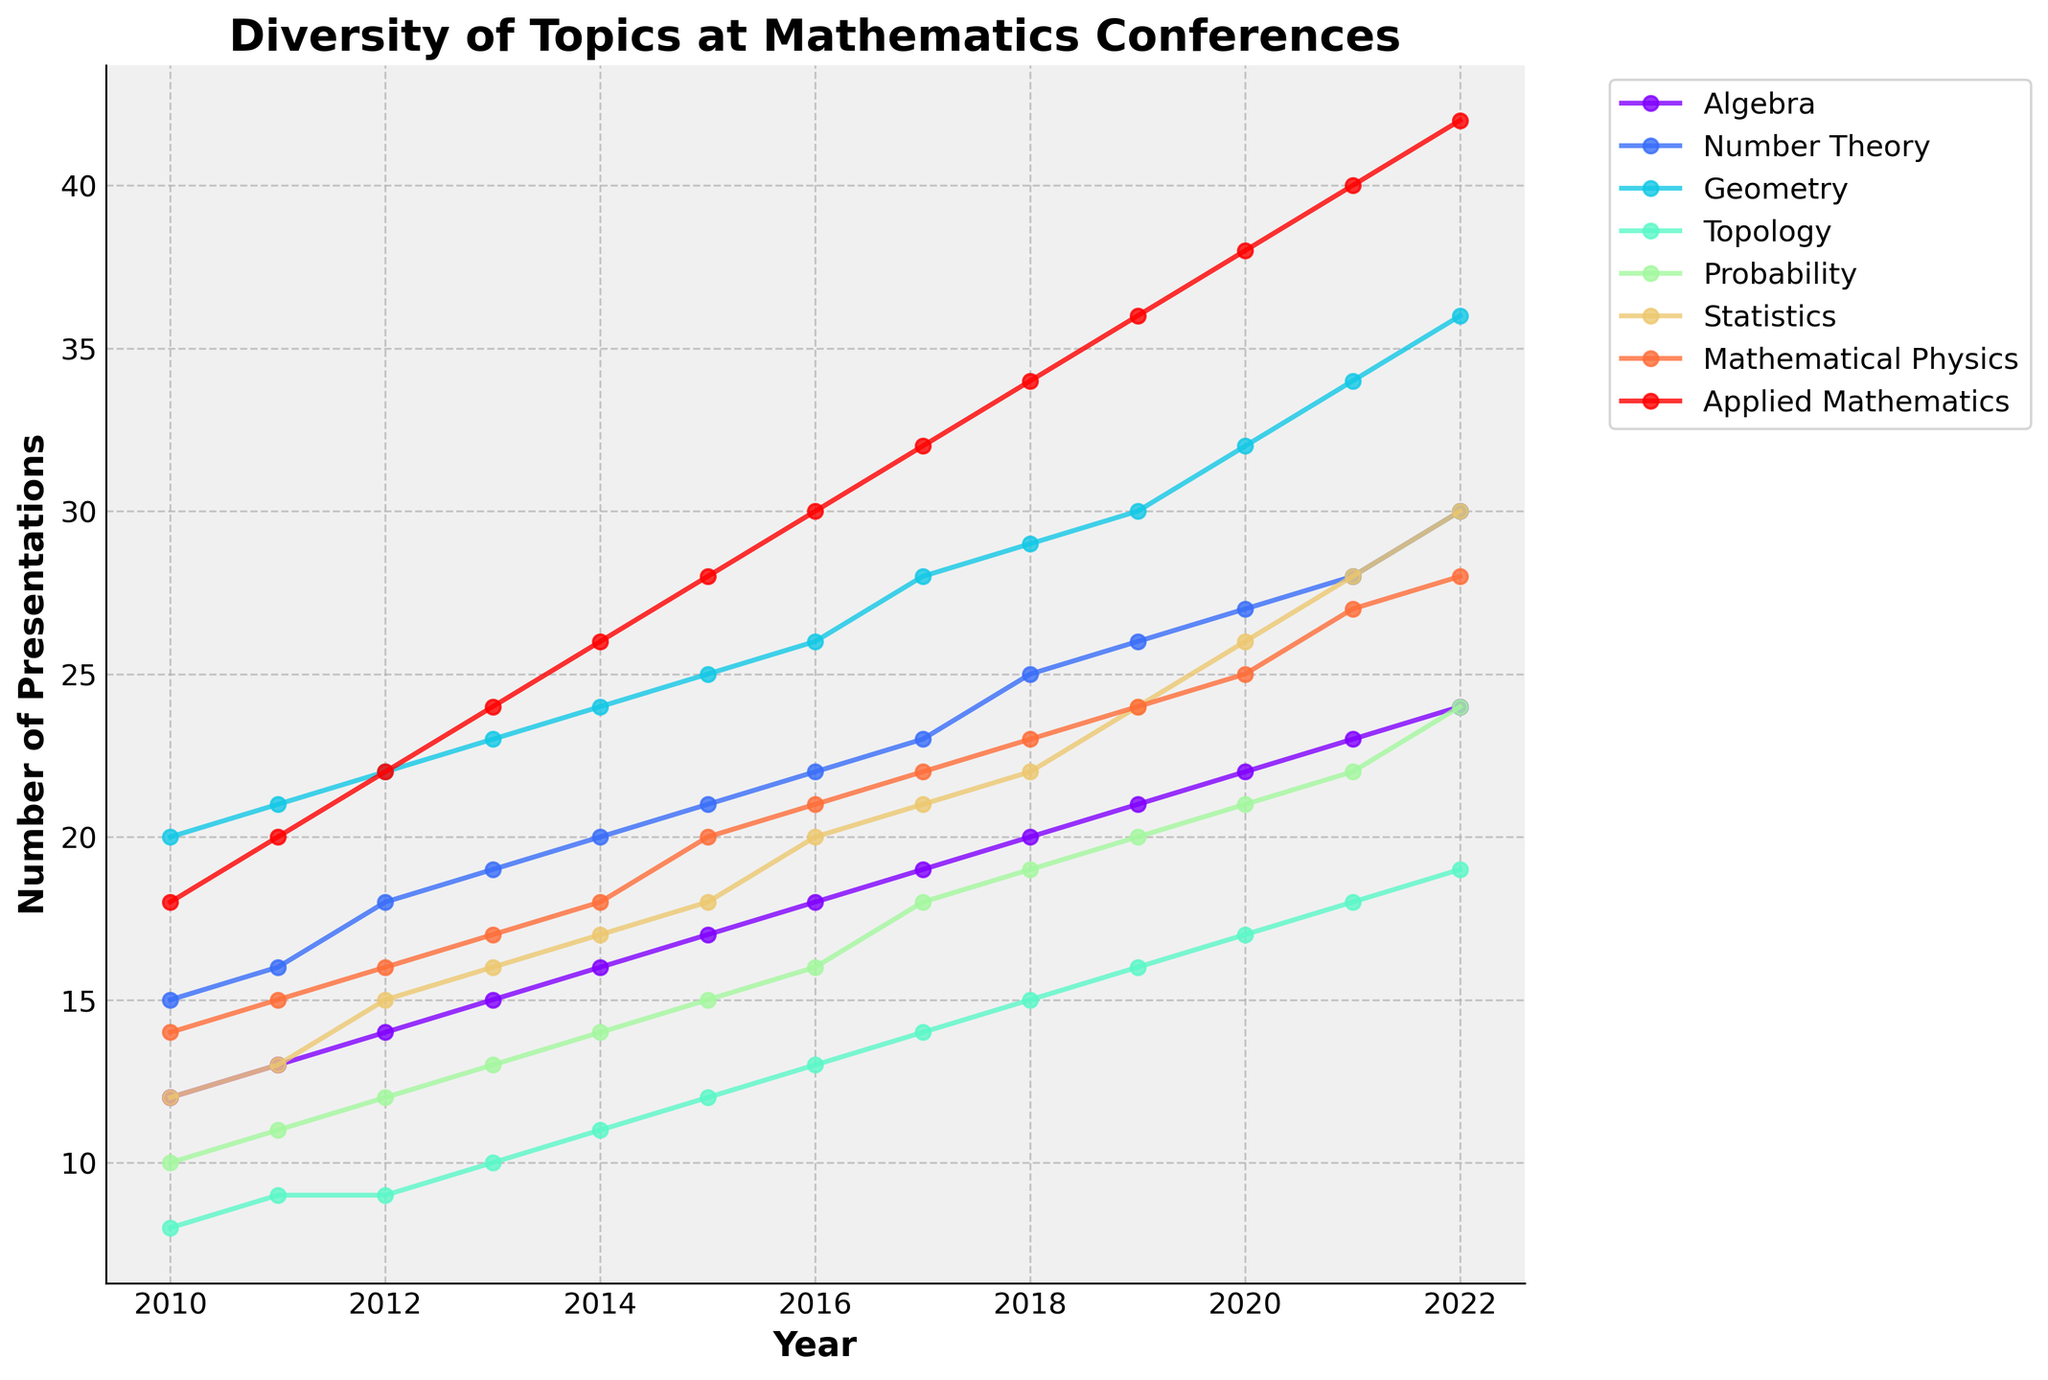How many categories are presented in the figure? The figure has lines representing different thematic categories of mathematics. By counting the unique lines or looking at the legend, we can determine that the categories are Algebra, Number Theory, Geometry, Topology, Probability, Statistics, Mathematical Physics, and Applied Mathematics.
Answer: 8 What is the title of the plot? The title is usually displayed at the top of the plot. In this case, it states the main focus of the plot which is 'Diversity of Topics at Mathematics Conferences'.
Answer: Diversity of Topics at Mathematics Conferences Which category had the highest number of presentations in 2022? To find this, we look at the values associated with each category in the year 2022. Applied Mathematics shows the highest value, which is 42 presentations.
Answer: Applied Mathematics What is the difference in the number of Geometry presentations between 2010 and 2022? For 2010, Geometry had 20 presentations. In 2022, it had 36 presentations. The difference is calculated by subtracting the 2010 value from the 2022 value: 36 - 20.
Answer: 16 Which year shows the steepest increase in the number of presentations for Topology compared to the previous year? To determine this, we compare the year-over-year changes. From 2017 to 2018, the increase was from 14 to 15, a difference of 1. From 2018 to 2019, it was from 15 to 16, again a difference of 1. From 2019 to 2020, it jumps from 16 to 17, also a difference of 1. From this observation, no single year shows a "steepest" major increase compared to previous years, suggesting a steady incremental pattern.
Answer: Steady incremental pattern Comparing Algebra and Probability, which category had a more consistent growth pattern over the years? To evaluate consistency, we observe the plotted lines for both categories. Algebra's line increases smoothly and steadily without sudden spikes, whereas Probability shows a more varied pattern with noticeable changes.
Answer: Algebra What has been the trend for Statistics presentations from 2010 to 2022? Observing the line representing Statistics, we note its upward trajectory, indicating a consistent increase in the number of presentations over the years.
Answer: Increasing In which year did Number Theory surpass 20 presentations? Looking at the Number Theory line, it crosses the 20-presentation mark between 2011 and 2012.
Answer: 2012 How much did the number of Applied Mathematics presentations increase from 2010 to 2022? The presentations in Applied Mathematics increased from 18 in 2010 to 42 in 2022. The increase is 42 - 18.
Answer: 24 What can be inferred about the overall trend in the diversity of topics presented at mathematics conferences? Evaluating all lines, we observe that almost all categories show an upward trend, suggesting an increase in the diversity of topics presented at mathematics conferences over the years.
Answer: Increasing diversity 